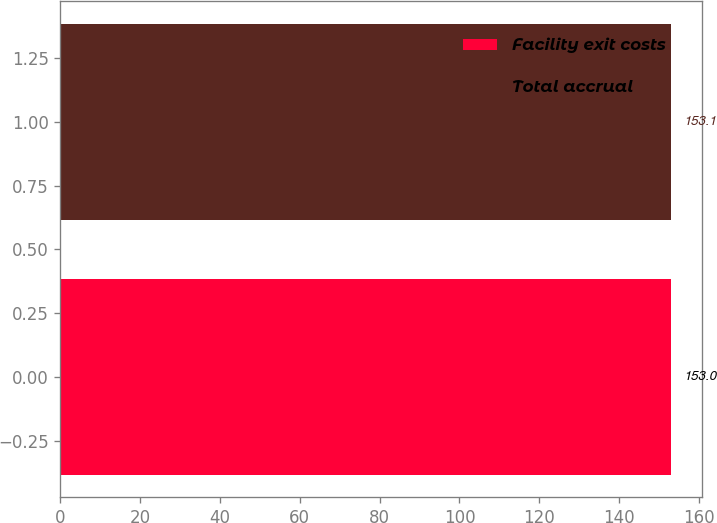Convert chart. <chart><loc_0><loc_0><loc_500><loc_500><bar_chart><fcel>Facility exit costs<fcel>Total accrual<nl><fcel>153<fcel>153.1<nl></chart> 